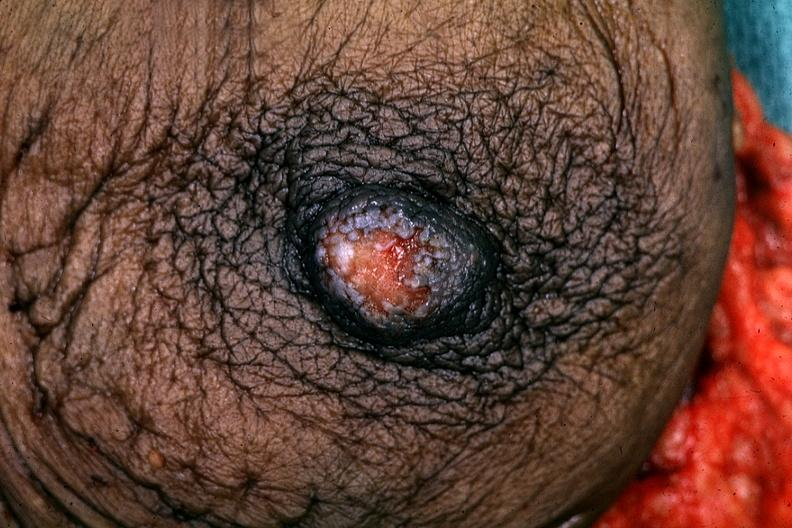s hours present?
Answer the question using a single word or phrase. No 